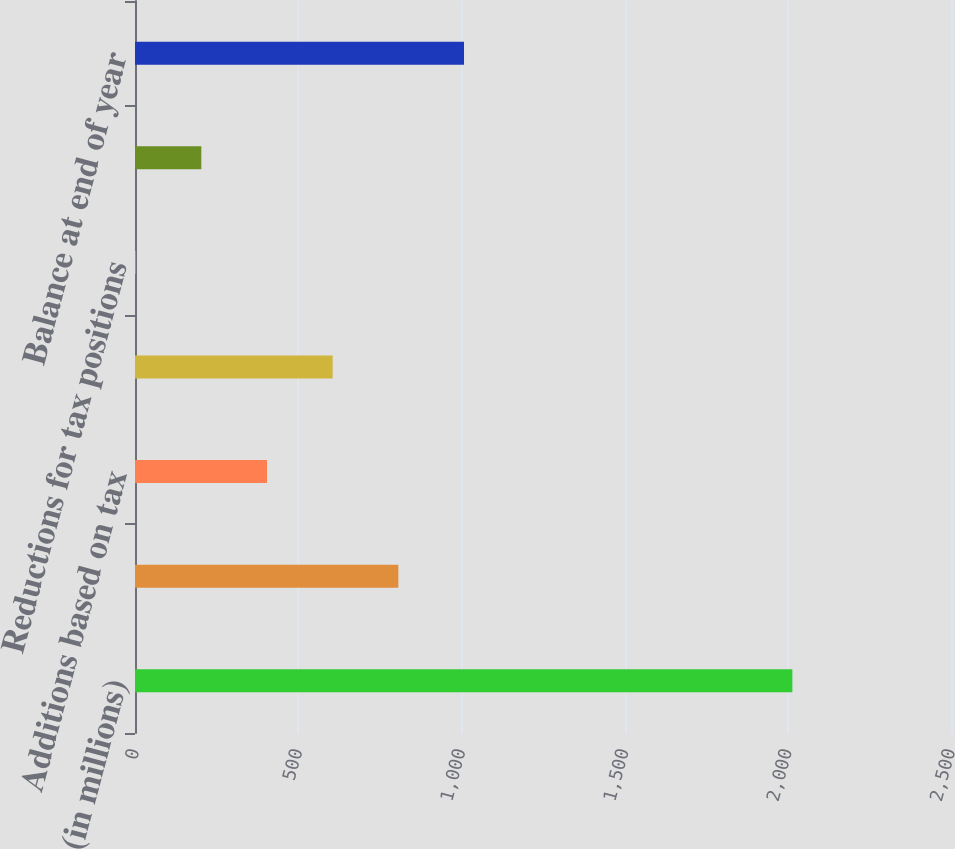Convert chart to OTSL. <chart><loc_0><loc_0><loc_500><loc_500><bar_chart><fcel>(in millions)<fcel>Balance at beginning of year<fcel>Additions based on tax<fcel>Additions for tax positions of<fcel>Reductions for tax positions<fcel>Settlements<fcel>Balance at end of year<nl><fcel>2014<fcel>806.8<fcel>404.4<fcel>605.6<fcel>2<fcel>203.2<fcel>1008<nl></chart> 